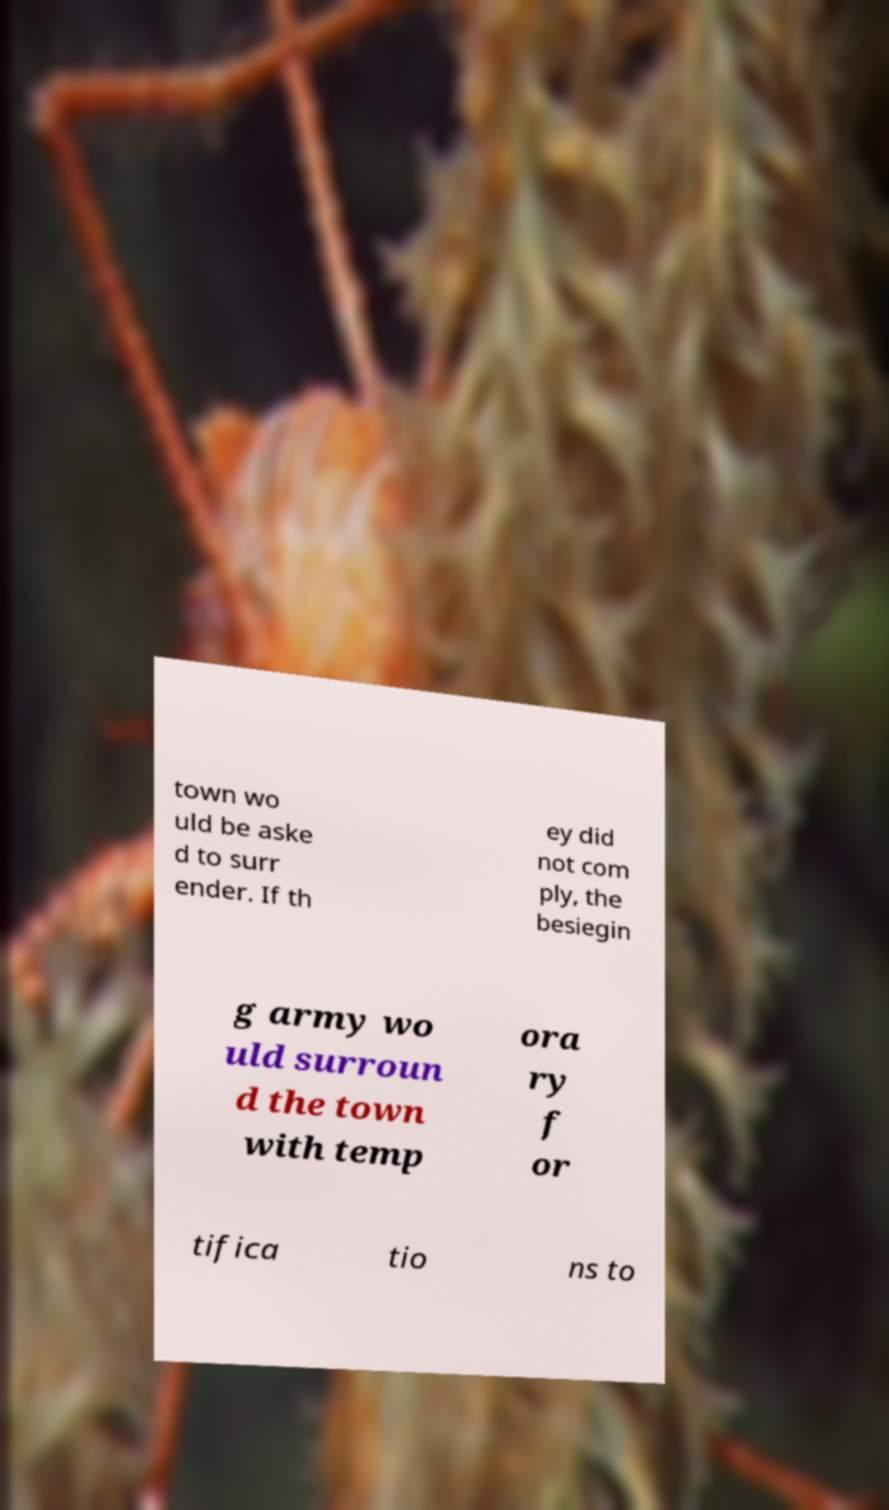I need the written content from this picture converted into text. Can you do that? town wo uld be aske d to surr ender. If th ey did not com ply, the besiegin g army wo uld surroun d the town with temp ora ry f or tifica tio ns to 